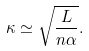<formula> <loc_0><loc_0><loc_500><loc_500>\kappa \simeq \sqrt { \frac { L } { n \alpha } } .</formula> 